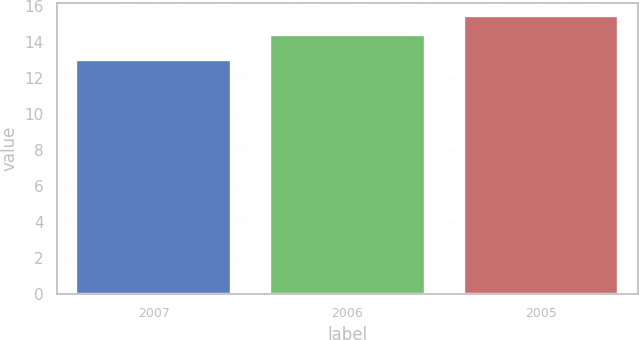Convert chart. <chart><loc_0><loc_0><loc_500><loc_500><bar_chart><fcel>2007<fcel>2006<fcel>2005<nl><fcel>13<fcel>14.4<fcel>15.4<nl></chart> 